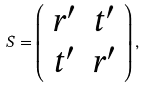Convert formula to latex. <formula><loc_0><loc_0><loc_500><loc_500>S = \left ( \begin{array} { c c } r ^ { \prime } & t ^ { \prime } \\ t ^ { \prime } & r ^ { \prime } \end{array} \right ) ,</formula> 